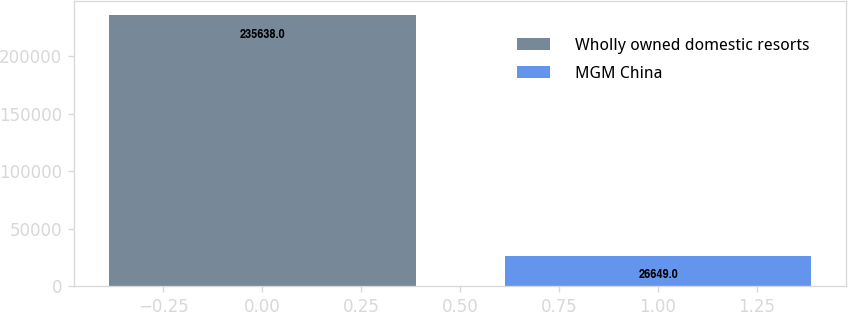Convert chart to OTSL. <chart><loc_0><loc_0><loc_500><loc_500><bar_chart><fcel>Wholly owned domestic resorts<fcel>MGM China<nl><fcel>235638<fcel>26649<nl></chart> 